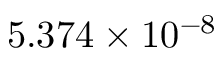Convert formula to latex. <formula><loc_0><loc_0><loc_500><loc_500>5 . 3 7 4 \times 1 0 ^ { - 8 }</formula> 